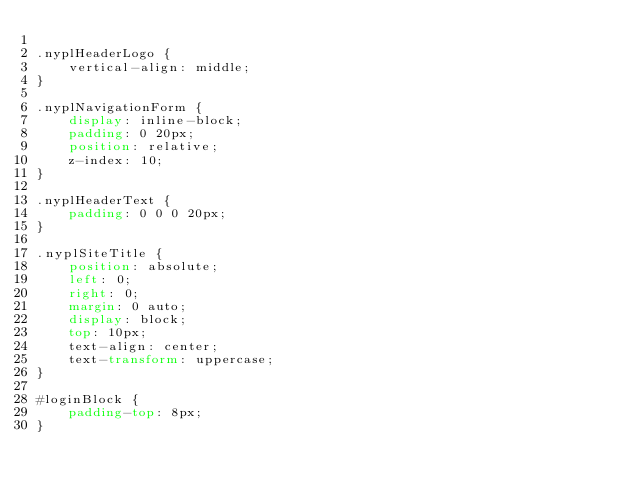<code> <loc_0><loc_0><loc_500><loc_500><_CSS_>
.nyplHeaderLogo {
    vertical-align: middle;
}

.nyplNavigationForm {
    display: inline-block;
    padding: 0 20px;
    position: relative;
    z-index: 10;
}

.nyplHeaderText {
    padding: 0 0 0 20px;
}

.nyplSiteTitle {
    position: absolute;
    left: 0;
    right: 0;
    margin: 0 auto;
    display: block;
    top: 10px;
    text-align: center;
    text-transform: uppercase;
}

#loginBlock {
    padding-top: 8px;
}</code> 